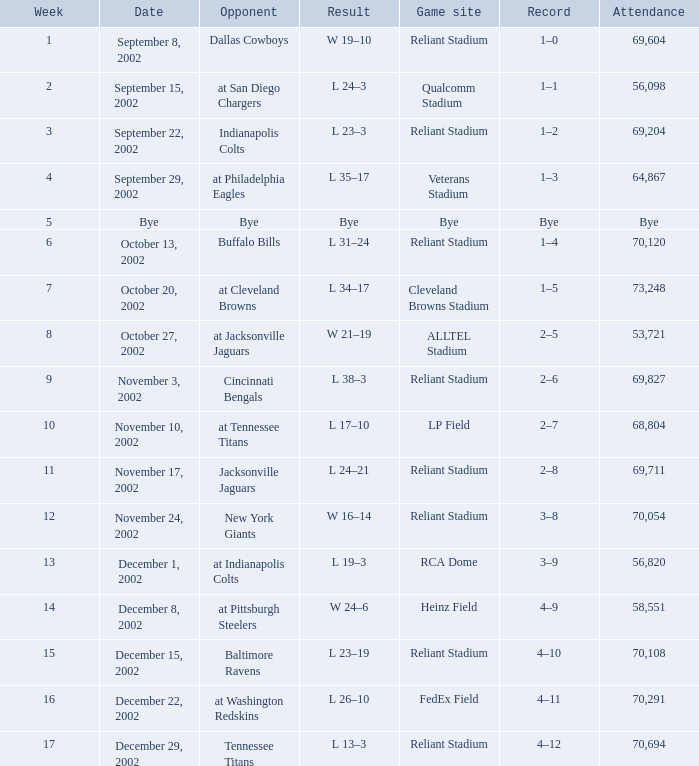What is the earliest week that the Texans played at the Cleveland Browns Stadium? 7.0. 